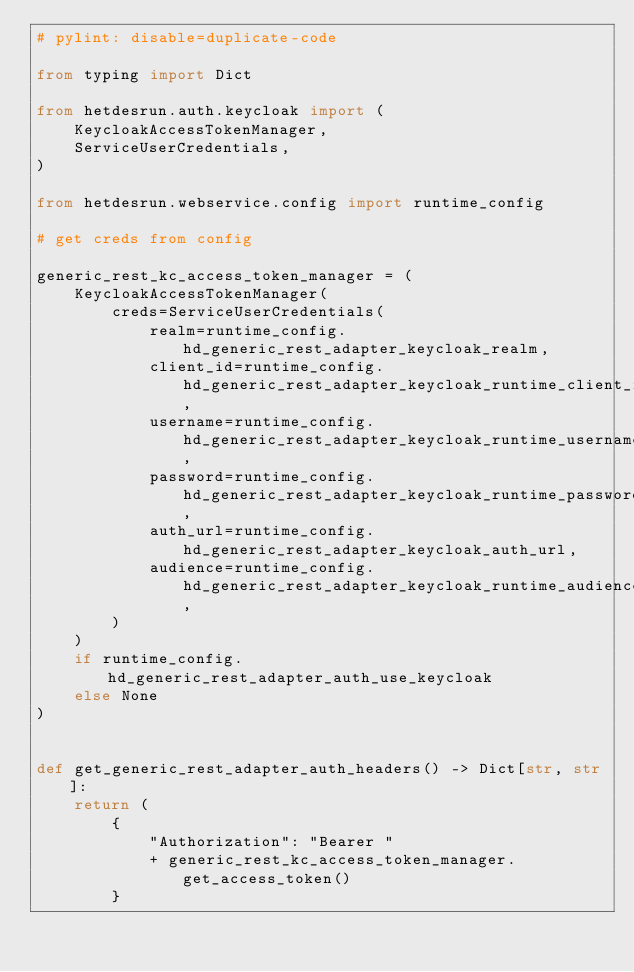<code> <loc_0><loc_0><loc_500><loc_500><_Python_># pylint: disable=duplicate-code

from typing import Dict

from hetdesrun.auth.keycloak import (
    KeycloakAccessTokenManager,
    ServiceUserCredentials,
)

from hetdesrun.webservice.config import runtime_config

# get creds from config

generic_rest_kc_access_token_manager = (
    KeycloakAccessTokenManager(
        creds=ServiceUserCredentials(
            realm=runtime_config.hd_generic_rest_adapter_keycloak_realm,
            client_id=runtime_config.hd_generic_rest_adapter_keycloak_runtime_client_id,
            username=runtime_config.hd_generic_rest_adapter_keycloak_runtime_username,
            password=runtime_config.hd_generic_rest_adapter_keycloak_runtime_password,
            auth_url=runtime_config.hd_generic_rest_adapter_keycloak_auth_url,
            audience=runtime_config.hd_generic_rest_adapter_keycloak_runtime_audience,
        )
    )
    if runtime_config.hd_generic_rest_adapter_auth_use_keycloak
    else None
)


def get_generic_rest_adapter_auth_headers() -> Dict[str, str]:
    return (
        {
            "Authorization": "Bearer "
            + generic_rest_kc_access_token_manager.get_access_token()
        }</code> 